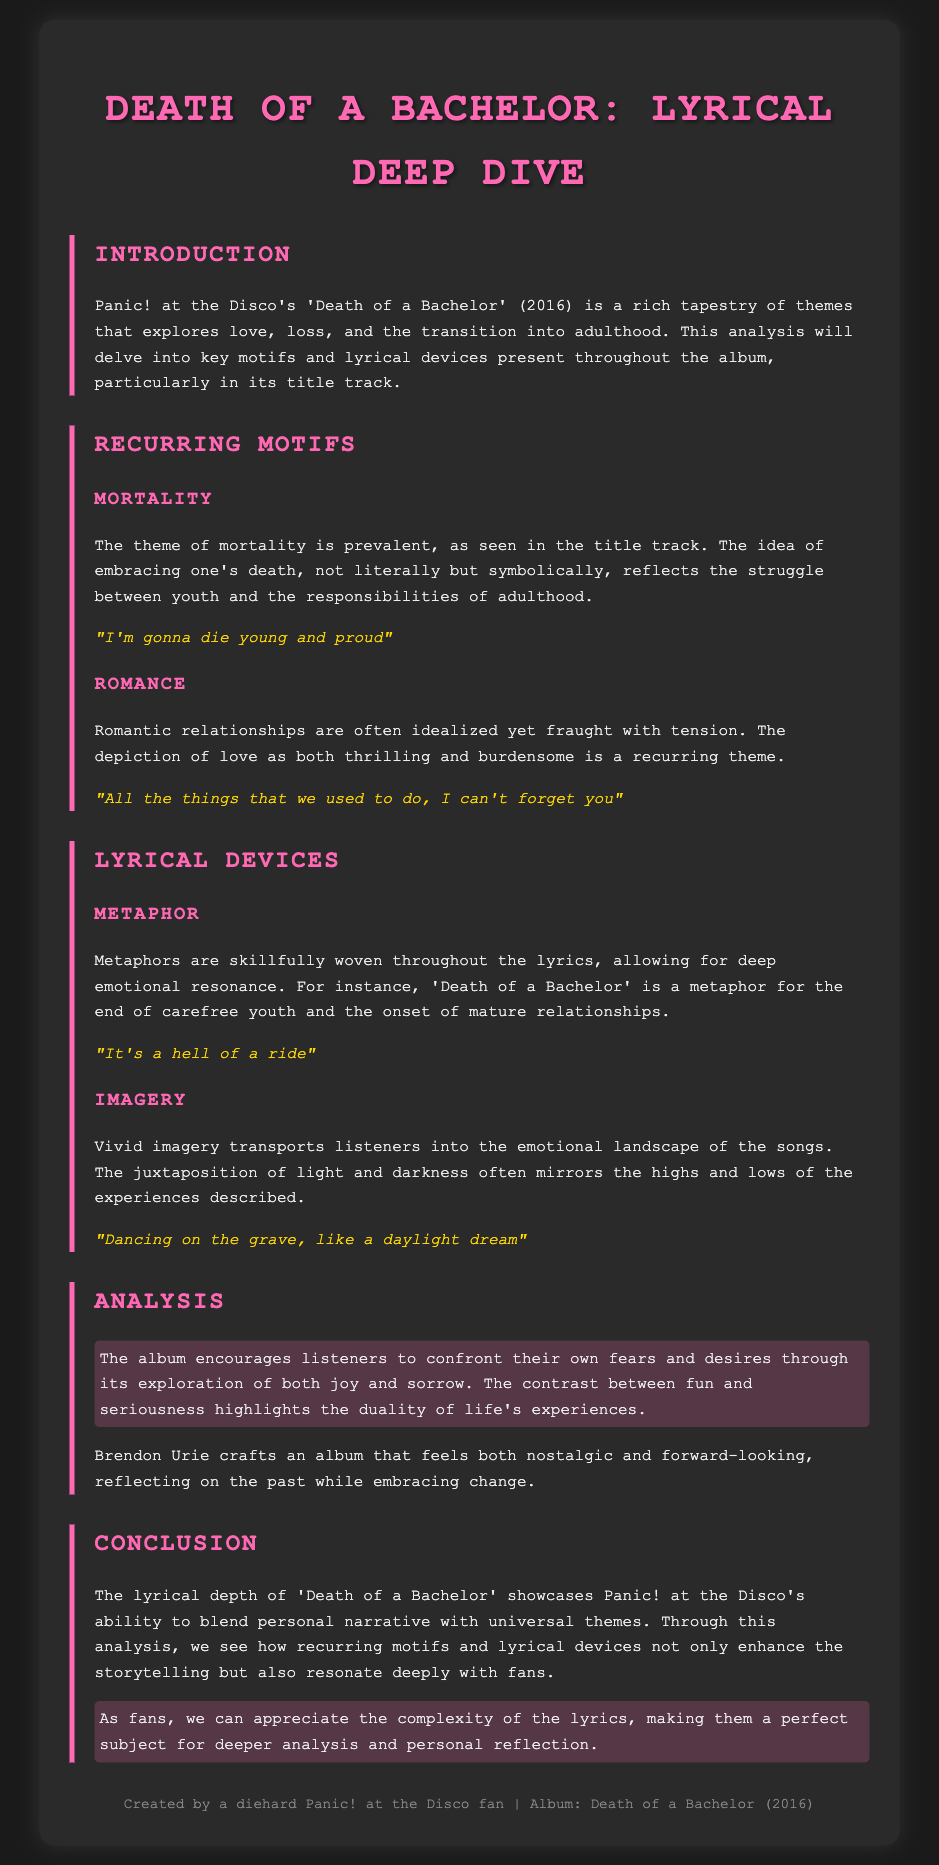What is the title of the album? The title of the album is explicitly mentioned as 'Death of a Bachelor' at the beginning of the document.
Answer: Death of a Bachelor Who is the artist of the album? The artist is identified in the introduction as Panic! at the Disco.
Answer: Panic! at the Disco What theme is prevalent in the title track? The document indicates that the theme of mortality is prevalent in the title track.
Answer: Mortality Give an example of a metaphor found in the lyrics. The document cites the phrase 'Death of a Bachelor' as a metaphor representing the end of carefree youth.
Answer: Death of a Bachelor What does the album encourage listeners to confront? The analysis in the document mentions that the album encourages listeners to confront their own fears and desires.
Answer: Fears and desires How does Brendon Urie view the past in the album? The text indicates that Brendon Urie reflects on the past while embracing change throughout the album.
Answer: Reflects on the past What color is emphasized in the document's headings? The headings are styled with a color that is specifically noted as pink.
Answer: Pink What lyrical device is used to create emotional resonance? The document explains that metaphors are used to create deep emotional resonance in the lyrics.
Answer: Metaphor What is a recurring theme in romantic relationships as per the analysis? The analysis indicates that romantic relationships are often depicted as both thrilling and burdensome.
Answer: Thrilling and burdensome 